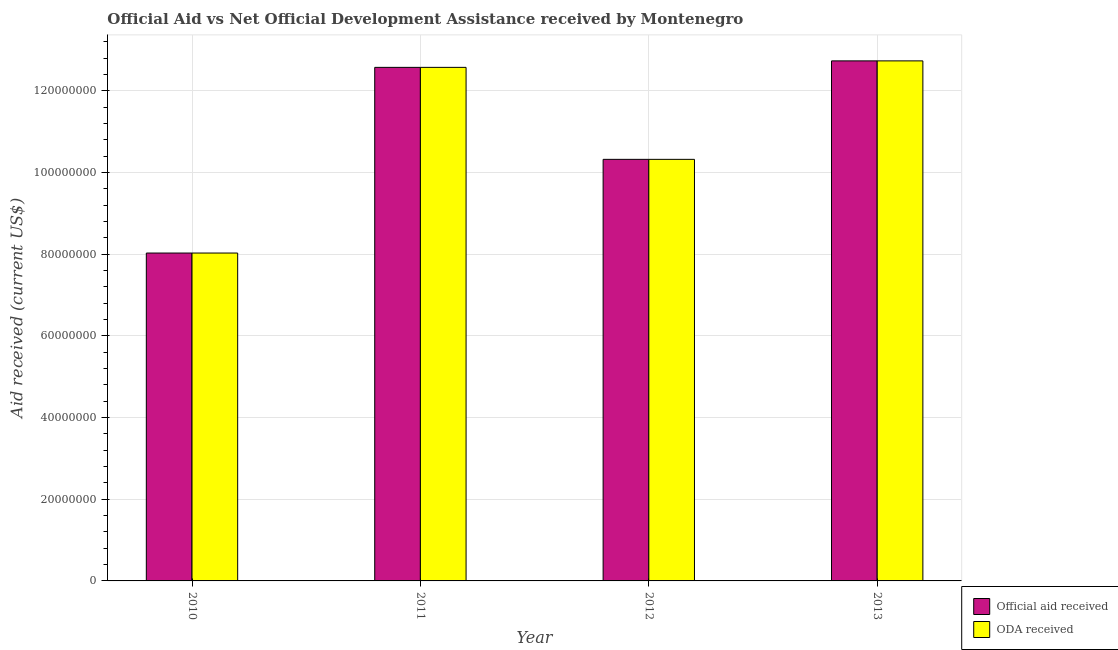How many different coloured bars are there?
Provide a short and direct response. 2. How many bars are there on the 1st tick from the right?
Offer a terse response. 2. In how many cases, is the number of bars for a given year not equal to the number of legend labels?
Your answer should be very brief. 0. What is the official aid received in 2011?
Offer a very short reply. 1.26e+08. Across all years, what is the maximum official aid received?
Offer a terse response. 1.27e+08. Across all years, what is the minimum official aid received?
Make the answer very short. 8.03e+07. What is the total oda received in the graph?
Offer a very short reply. 4.37e+08. What is the difference between the oda received in 2010 and that in 2013?
Keep it short and to the point. -4.70e+07. What is the difference between the official aid received in 2012 and the oda received in 2011?
Ensure brevity in your answer.  -2.25e+07. What is the average oda received per year?
Ensure brevity in your answer.  1.09e+08. In the year 2012, what is the difference between the oda received and official aid received?
Provide a short and direct response. 0. In how many years, is the oda received greater than 20000000 US$?
Make the answer very short. 4. What is the ratio of the oda received in 2010 to that in 2011?
Offer a terse response. 0.64. Is the official aid received in 2010 less than that in 2011?
Your response must be concise. Yes. Is the difference between the official aid received in 2010 and 2012 greater than the difference between the oda received in 2010 and 2012?
Provide a succinct answer. No. What is the difference between the highest and the second highest official aid received?
Offer a terse response. 1.59e+06. What is the difference between the highest and the lowest oda received?
Offer a very short reply. 4.70e+07. Is the sum of the oda received in 2010 and 2011 greater than the maximum official aid received across all years?
Make the answer very short. Yes. What does the 1st bar from the left in 2012 represents?
Provide a succinct answer. Official aid received. What does the 1st bar from the right in 2013 represents?
Offer a terse response. ODA received. How many bars are there?
Offer a very short reply. 8. Are the values on the major ticks of Y-axis written in scientific E-notation?
Give a very brief answer. No. Does the graph contain any zero values?
Provide a short and direct response. No. Does the graph contain grids?
Keep it short and to the point. Yes. What is the title of the graph?
Ensure brevity in your answer.  Official Aid vs Net Official Development Assistance received by Montenegro . What is the label or title of the Y-axis?
Keep it short and to the point. Aid received (current US$). What is the Aid received (current US$) in Official aid received in 2010?
Keep it short and to the point. 8.03e+07. What is the Aid received (current US$) of ODA received in 2010?
Make the answer very short. 8.03e+07. What is the Aid received (current US$) of Official aid received in 2011?
Your response must be concise. 1.26e+08. What is the Aid received (current US$) of ODA received in 2011?
Your answer should be compact. 1.26e+08. What is the Aid received (current US$) of Official aid received in 2012?
Ensure brevity in your answer.  1.03e+08. What is the Aid received (current US$) of ODA received in 2012?
Give a very brief answer. 1.03e+08. What is the Aid received (current US$) of Official aid received in 2013?
Make the answer very short. 1.27e+08. What is the Aid received (current US$) in ODA received in 2013?
Ensure brevity in your answer.  1.27e+08. Across all years, what is the maximum Aid received (current US$) of Official aid received?
Give a very brief answer. 1.27e+08. Across all years, what is the maximum Aid received (current US$) in ODA received?
Offer a terse response. 1.27e+08. Across all years, what is the minimum Aid received (current US$) in Official aid received?
Give a very brief answer. 8.03e+07. Across all years, what is the minimum Aid received (current US$) of ODA received?
Provide a succinct answer. 8.03e+07. What is the total Aid received (current US$) in Official aid received in the graph?
Ensure brevity in your answer.  4.37e+08. What is the total Aid received (current US$) of ODA received in the graph?
Provide a succinct answer. 4.37e+08. What is the difference between the Aid received (current US$) of Official aid received in 2010 and that in 2011?
Ensure brevity in your answer.  -4.55e+07. What is the difference between the Aid received (current US$) in ODA received in 2010 and that in 2011?
Your response must be concise. -4.55e+07. What is the difference between the Aid received (current US$) of Official aid received in 2010 and that in 2012?
Provide a succinct answer. -2.29e+07. What is the difference between the Aid received (current US$) in ODA received in 2010 and that in 2012?
Provide a succinct answer. -2.29e+07. What is the difference between the Aid received (current US$) of Official aid received in 2010 and that in 2013?
Give a very brief answer. -4.70e+07. What is the difference between the Aid received (current US$) of ODA received in 2010 and that in 2013?
Your answer should be compact. -4.70e+07. What is the difference between the Aid received (current US$) in Official aid received in 2011 and that in 2012?
Provide a succinct answer. 2.25e+07. What is the difference between the Aid received (current US$) of ODA received in 2011 and that in 2012?
Provide a short and direct response. 2.25e+07. What is the difference between the Aid received (current US$) in Official aid received in 2011 and that in 2013?
Ensure brevity in your answer.  -1.59e+06. What is the difference between the Aid received (current US$) of ODA received in 2011 and that in 2013?
Offer a terse response. -1.59e+06. What is the difference between the Aid received (current US$) of Official aid received in 2012 and that in 2013?
Keep it short and to the point. -2.41e+07. What is the difference between the Aid received (current US$) of ODA received in 2012 and that in 2013?
Keep it short and to the point. -2.41e+07. What is the difference between the Aid received (current US$) in Official aid received in 2010 and the Aid received (current US$) in ODA received in 2011?
Provide a short and direct response. -4.55e+07. What is the difference between the Aid received (current US$) of Official aid received in 2010 and the Aid received (current US$) of ODA received in 2012?
Offer a terse response. -2.29e+07. What is the difference between the Aid received (current US$) in Official aid received in 2010 and the Aid received (current US$) in ODA received in 2013?
Keep it short and to the point. -4.70e+07. What is the difference between the Aid received (current US$) in Official aid received in 2011 and the Aid received (current US$) in ODA received in 2012?
Provide a succinct answer. 2.25e+07. What is the difference between the Aid received (current US$) in Official aid received in 2011 and the Aid received (current US$) in ODA received in 2013?
Provide a succinct answer. -1.59e+06. What is the difference between the Aid received (current US$) in Official aid received in 2012 and the Aid received (current US$) in ODA received in 2013?
Keep it short and to the point. -2.41e+07. What is the average Aid received (current US$) of Official aid received per year?
Provide a succinct answer. 1.09e+08. What is the average Aid received (current US$) in ODA received per year?
Offer a terse response. 1.09e+08. In the year 2011, what is the difference between the Aid received (current US$) in Official aid received and Aid received (current US$) in ODA received?
Provide a short and direct response. 0. In the year 2012, what is the difference between the Aid received (current US$) in Official aid received and Aid received (current US$) in ODA received?
Your answer should be very brief. 0. In the year 2013, what is the difference between the Aid received (current US$) in Official aid received and Aid received (current US$) in ODA received?
Your answer should be very brief. 0. What is the ratio of the Aid received (current US$) of Official aid received in 2010 to that in 2011?
Ensure brevity in your answer.  0.64. What is the ratio of the Aid received (current US$) of ODA received in 2010 to that in 2011?
Offer a terse response. 0.64. What is the ratio of the Aid received (current US$) of ODA received in 2010 to that in 2012?
Provide a short and direct response. 0.78. What is the ratio of the Aid received (current US$) of Official aid received in 2010 to that in 2013?
Give a very brief answer. 0.63. What is the ratio of the Aid received (current US$) in ODA received in 2010 to that in 2013?
Provide a short and direct response. 0.63. What is the ratio of the Aid received (current US$) in Official aid received in 2011 to that in 2012?
Provide a short and direct response. 1.22. What is the ratio of the Aid received (current US$) in ODA received in 2011 to that in 2012?
Offer a very short reply. 1.22. What is the ratio of the Aid received (current US$) in Official aid received in 2011 to that in 2013?
Provide a short and direct response. 0.99. What is the ratio of the Aid received (current US$) in ODA received in 2011 to that in 2013?
Keep it short and to the point. 0.99. What is the ratio of the Aid received (current US$) of Official aid received in 2012 to that in 2013?
Keep it short and to the point. 0.81. What is the ratio of the Aid received (current US$) in ODA received in 2012 to that in 2013?
Your answer should be very brief. 0.81. What is the difference between the highest and the second highest Aid received (current US$) in Official aid received?
Give a very brief answer. 1.59e+06. What is the difference between the highest and the second highest Aid received (current US$) in ODA received?
Make the answer very short. 1.59e+06. What is the difference between the highest and the lowest Aid received (current US$) of Official aid received?
Provide a short and direct response. 4.70e+07. What is the difference between the highest and the lowest Aid received (current US$) in ODA received?
Give a very brief answer. 4.70e+07. 